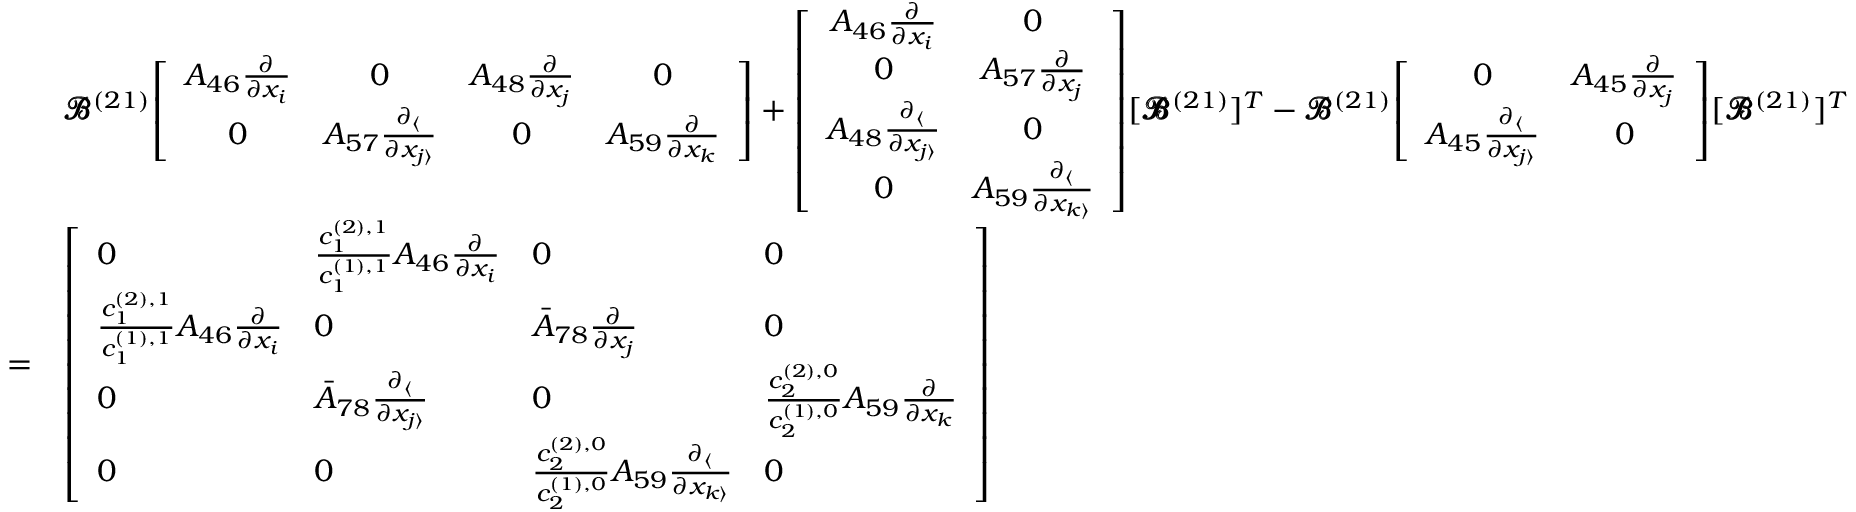Convert formula to latex. <formula><loc_0><loc_0><loc_500><loc_500>\begin{array} { r l } & { \pm b { \ m a t h s c r { B } } ^ { ( 2 1 ) } \, \left [ \begin{array} { c c c c } { A _ { 4 6 } \frac { \partial } { \partial x _ { i } } } & { 0 } & { A _ { 4 8 } \frac { \partial } { \partial x _ { j } } } & { 0 } \\ { 0 } & { A _ { 5 7 } \frac { \partial _ { \langle } } { \partial x _ { j \rangle } } } & { 0 } & { A _ { 5 9 } \frac { \partial } { \partial x _ { k } } } \end{array} \right ] + \left [ \begin{array} { c c } { A _ { 4 6 } \frac { \partial } { \partial x _ { i } } } & { 0 } \\ { 0 } & { A _ { 5 7 } \frac { \partial } { \partial x _ { j } } } \\ { A _ { 4 8 } \frac { \partial _ { \langle } } { \partial x _ { j \rangle } } } & { 0 } \\ { 0 } & { A _ { 5 9 } \frac { \partial _ { \langle } } { \partial x _ { k \rangle } } } \end{array} \right ] \, [ \pm b { \ m a t h s c r { B } } ^ { ( 2 1 ) } ] ^ { T } - \pm b { \ m a t h s c r { B } } ^ { ( 2 1 ) } \, \left [ \begin{array} { c c } { 0 } & { A _ { 4 5 } \frac { \partial } { \partial x _ { j } } } \\ { A _ { 4 5 } \frac { \partial _ { \langle } } { \partial x _ { j \rangle } } } & { 0 } \end{array} \right ] \, [ \pm b { \ m a t h s c r { B } } ^ { ( 2 1 ) } ] ^ { T } } \\ { = } & { \left [ \begin{array} { l l l l } { 0 } & { \frac { c _ { 1 } ^ { ( 2 ) , 1 } } { c _ { 1 } ^ { ( 1 ) , 1 } } A _ { 4 6 } \frac { \partial } { \partial x _ { i } } } & { 0 } & { 0 } \\ { \frac { c _ { 1 } ^ { ( 2 ) , 1 } } { c _ { 1 } ^ { ( 1 ) , 1 } } A _ { 4 6 } \frac { \partial } { \partial x _ { i } } } & { 0 } & { \bar { A } _ { 7 8 } \frac { \partial } { \partial x _ { j } } } & { 0 } \\ { 0 } & { \bar { A } _ { 7 8 } \frac { \partial _ { \langle } } { \partial x _ { j \rangle } } } & { 0 } & { \frac { c _ { 2 } ^ { ( 2 ) , 0 } } { c _ { 2 } ^ { ( 1 ) , 0 } } A _ { 5 9 } \frac { \partial } { \partial x _ { k } } } \\ { 0 } & { 0 } & { \frac { c _ { 2 } ^ { ( 2 ) , 0 } } { c _ { 2 } ^ { ( 1 ) , 0 } } A _ { 5 9 } \frac { \partial _ { \langle } } { \partial x _ { k \rangle } } } & { 0 } \end{array} \right ] } \end{array}</formula> 